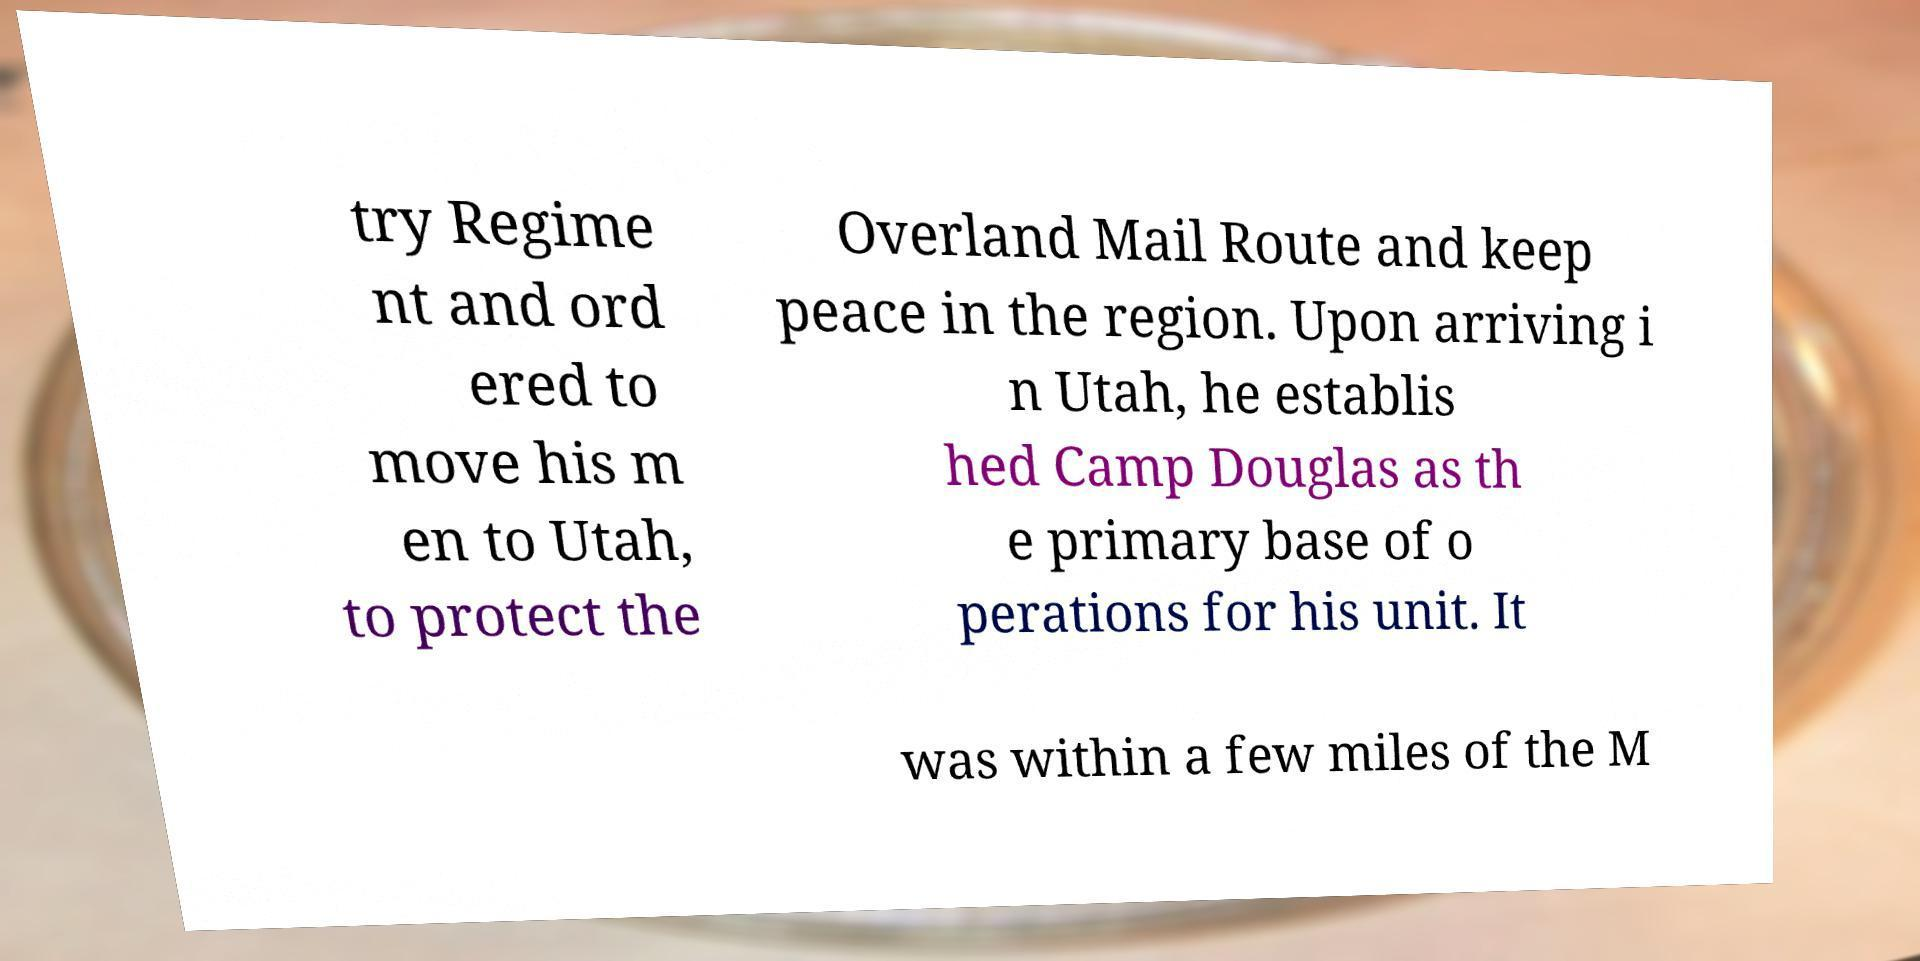Could you assist in decoding the text presented in this image and type it out clearly? try Regime nt and ord ered to move his m en to Utah, to protect the Overland Mail Route and keep peace in the region. Upon arriving i n Utah, he establis hed Camp Douglas as th e primary base of o perations for his unit. It was within a few miles of the M 